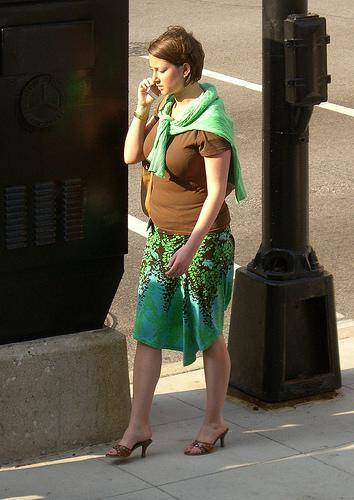Question: what color shirt is the woman wearing?
Choices:
A. White.
B. Red.
C. Orange.
D. Brown.
Answer with the letter. Answer: D Question: what is the woman doing?
Choices:
A. Reading a book.
B. Walking.
C. Swimming.
D. Talking on the phone.
Answer with the letter. Answer: D Question: what color is the pole?
Choices:
A. Brown.
B. Red.
C. Black.
D. Blue.
Answer with the letter. Answer: C Question: what does the woman have in her hand?
Choices:
A. Purse.
B. Leash.
C. Umbrella.
D. A phone.
Answer with the letter. Answer: D 